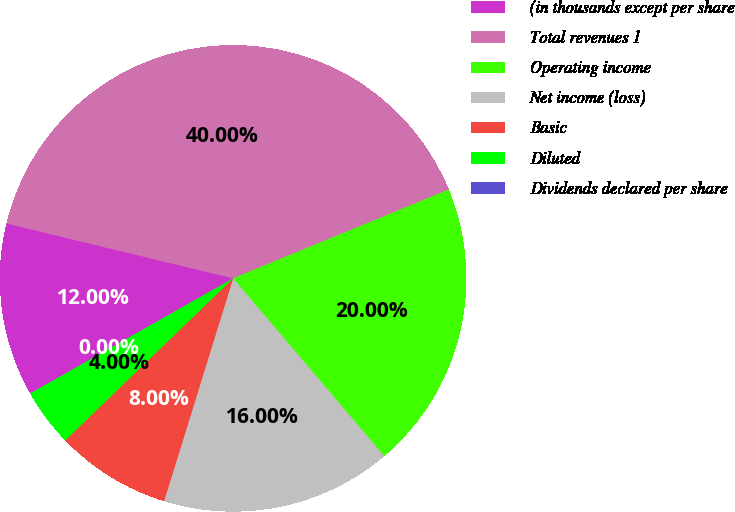Convert chart to OTSL. <chart><loc_0><loc_0><loc_500><loc_500><pie_chart><fcel>(in thousands except per share<fcel>Total revenues 1<fcel>Operating income<fcel>Net income (loss)<fcel>Basic<fcel>Diluted<fcel>Dividends declared per share<nl><fcel>12.0%<fcel>40.0%<fcel>20.0%<fcel>16.0%<fcel>8.0%<fcel>4.0%<fcel>0.0%<nl></chart> 